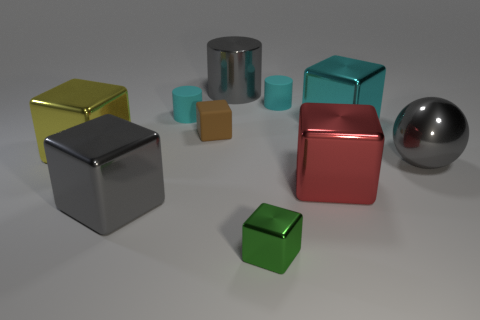Is there a tiny cyan cylinder that has the same material as the small brown cube?
Your answer should be very brief. Yes. What number of small blue matte blocks are there?
Offer a very short reply. 0. There is a object that is in front of the large gray metal thing that is in front of the gray sphere; what is it made of?
Give a very brief answer. Metal. The tiny object that is made of the same material as the gray ball is what color?
Your answer should be very brief. Green. There is a cylinder on the right side of the small metallic thing; is its size the same as the gray thing right of the cyan metal object?
Offer a terse response. No. How many balls are either tiny green rubber objects or big cyan things?
Your response must be concise. 0. Is the material of the tiny cylinder on the right side of the large gray cylinder the same as the brown cube?
Offer a terse response. Yes. What number of other objects are there of the same size as the shiny ball?
Offer a terse response. 5. How many tiny things are either brown rubber blocks or purple metallic things?
Make the answer very short. 1. Is the color of the big metallic cylinder the same as the large ball?
Ensure brevity in your answer.  Yes. 